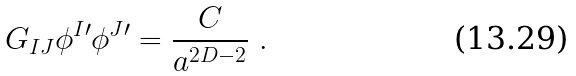Convert formula to latex. <formula><loc_0><loc_0><loc_500><loc_500>G _ { I J } \phi ^ { I \prime } \phi ^ { J \prime } = \frac { C } { a ^ { 2 D - 2 } } \ .</formula> 